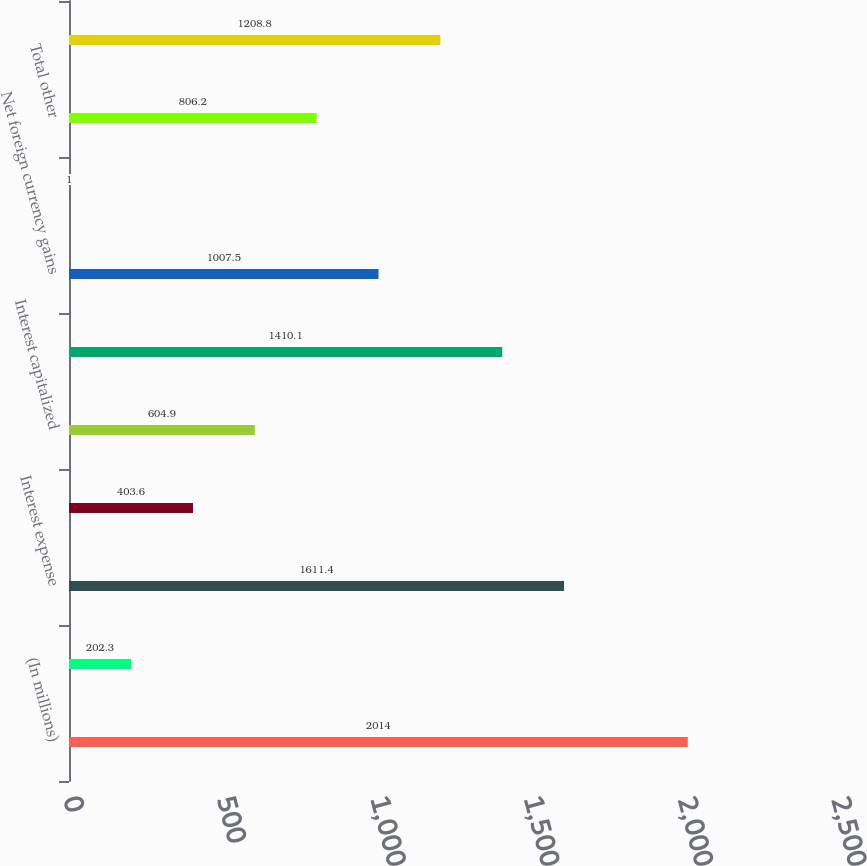Convert chart. <chart><loc_0><loc_0><loc_500><loc_500><bar_chart><fcel>(In millions)<fcel>Interest income<fcel>Interest expense<fcel>Income on interest rate swaps<fcel>Interest capitalized<fcel>Total interest<fcel>Net foreign currency gains<fcel>Other<fcel>Total other<fcel>Net interest and other<nl><fcel>2014<fcel>202.3<fcel>1611.4<fcel>403.6<fcel>604.9<fcel>1410.1<fcel>1007.5<fcel>1<fcel>806.2<fcel>1208.8<nl></chart> 